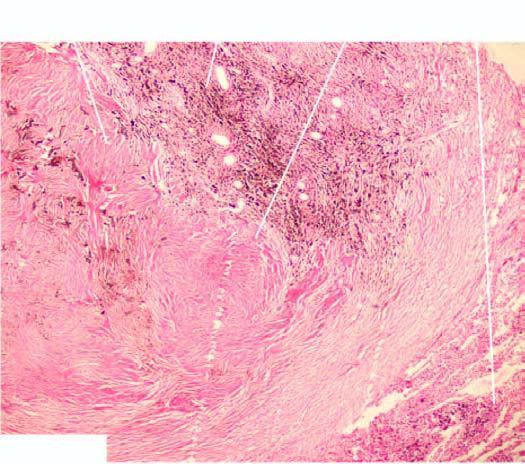re the alveoli and respiratory bronchioles surrounding the coal macule distended?
Answer the question using a single word or phrase. Yes 